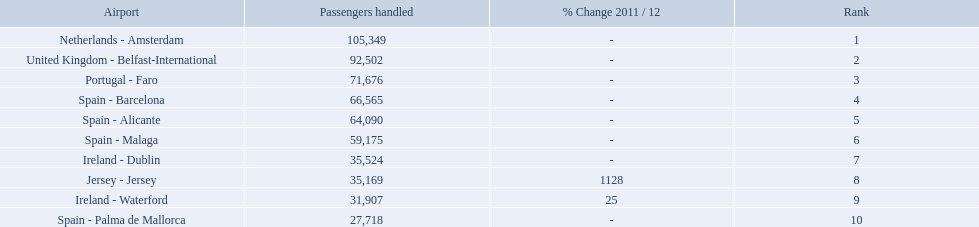Can you parse all the data within this table? {'header': ['Airport', 'Passengers handled', '% Change 2011 / 12', 'Rank'], 'rows': [['Netherlands - Amsterdam', '105,349', '-', '1'], ['United Kingdom - Belfast-International', '92,502', '-', '2'], ['Portugal - Faro', '71,676', '-', '3'], ['Spain - Barcelona', '66,565', '-', '4'], ['Spain - Alicante', '64,090', '-', '5'], ['Spain - Malaga', '59,175', '-', '6'], ['Ireland - Dublin', '35,524', '-', '7'], ['Jersey - Jersey', '35,169', '1128', '8'], ['Ireland - Waterford', '31,907', '25', '9'], ['Spain - Palma de Mallorca', '27,718', '-', '10']]} Which airports had passengers going through london southend airport? Netherlands - Amsterdam, United Kingdom - Belfast-International, Portugal - Faro, Spain - Barcelona, Spain - Alicante, Spain - Malaga, Ireland - Dublin, Jersey - Jersey, Ireland - Waterford, Spain - Palma de Mallorca. Of those airports, which airport had the least amount of passengers going through london southend airport? Spain - Palma de Mallorca. What are the 10 busiest routes to and from london southend airport? Netherlands - Amsterdam, United Kingdom - Belfast-International, Portugal - Faro, Spain - Barcelona, Spain - Alicante, Spain - Malaga, Ireland - Dublin, Jersey - Jersey, Ireland - Waterford, Spain - Palma de Mallorca. Of these, which airport is in portugal? Portugal - Faro. What are all of the airports? Netherlands - Amsterdam, United Kingdom - Belfast-International, Portugal - Faro, Spain - Barcelona, Spain - Alicante, Spain - Malaga, Ireland - Dublin, Jersey - Jersey, Ireland - Waterford, Spain - Palma de Mallorca. How many passengers have they handled? 105,349, 92,502, 71,676, 66,565, 64,090, 59,175, 35,524, 35,169, 31,907, 27,718. And which airport has handled the most passengers? Netherlands - Amsterdam. 